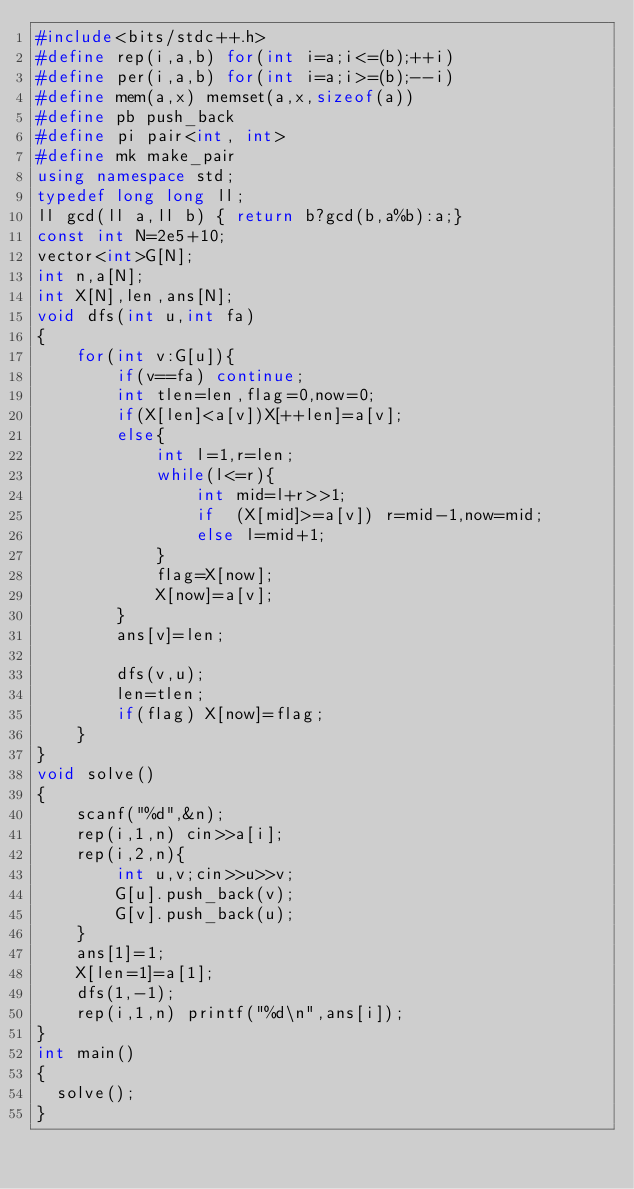Convert code to text. <code><loc_0><loc_0><loc_500><loc_500><_C++_>#include<bits/stdc++.h>
#define rep(i,a,b) for(int i=a;i<=(b);++i)
#define per(i,a,b) for(int i=a;i>=(b);--i)
#define mem(a,x) memset(a,x,sizeof(a))
#define pb push_back
#define pi pair<int, int>
#define mk make_pair
using namespace std;
typedef long long ll;
ll gcd(ll a,ll b) { return b?gcd(b,a%b):a;}
const int N=2e5+10;
vector<int>G[N];
int n,a[N];
int X[N],len,ans[N];
void dfs(int u,int fa)
{
    for(int v:G[u]){
        if(v==fa) continue;
        int tlen=len,flag=0,now=0;
        if(X[len]<a[v])X[++len]=a[v];
        else{
            int l=1,r=len;
            while(l<=r){
                int mid=l+r>>1;
                if  (X[mid]>=a[v]) r=mid-1,now=mid;
                else l=mid+1;
            }
            flag=X[now];
            X[now]=a[v];
        }
        ans[v]=len;

        dfs(v,u);
        len=tlen;
        if(flag) X[now]=flag;
    }
}
void solve()
{
    scanf("%d",&n);
    rep(i,1,n) cin>>a[i];
    rep(i,2,n){
        int u,v;cin>>u>>v;
        G[u].push_back(v);
        G[v].push_back(u);
    }
    ans[1]=1;
    X[len=1]=a[1];
    dfs(1,-1);
    rep(i,1,n) printf("%d\n",ans[i]);
}
int main()
{
	solve();
}
</code> 